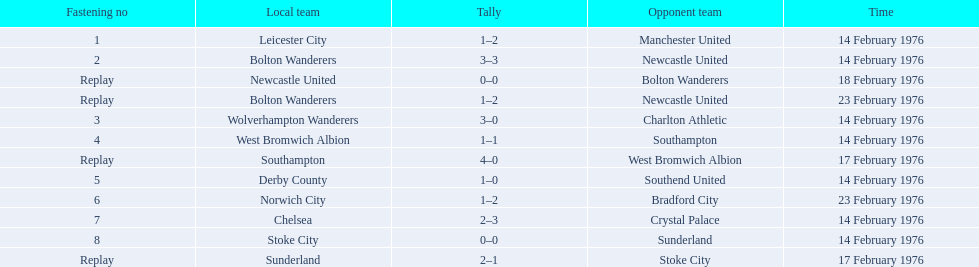Who was the home team in the game on the top of the table? Leicester City. 